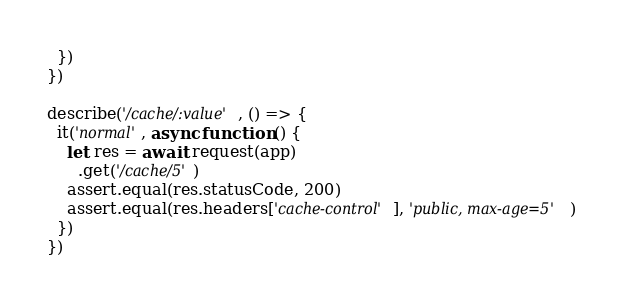Convert code to text. <code><loc_0><loc_0><loc_500><loc_500><_JavaScript_>  })
})

describe('/cache/:value', () => {
  it('normal', async function () {
    let res = await request(app)
      .get('/cache/5')
    assert.equal(res.statusCode, 200)
    assert.equal(res.headers['cache-control'], 'public, max-age=5')
  })
})
</code> 